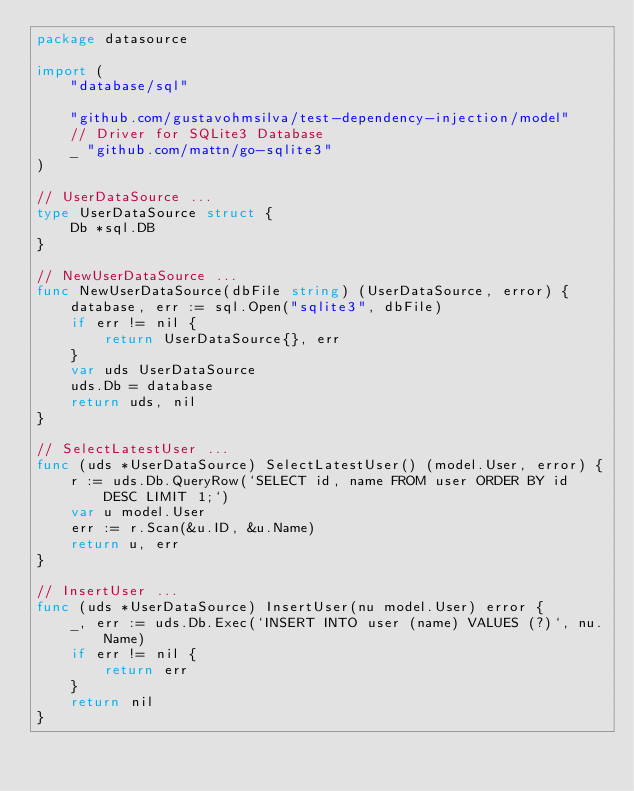Convert code to text. <code><loc_0><loc_0><loc_500><loc_500><_Go_>package datasource

import (
	"database/sql"

	"github.com/gustavohmsilva/test-dependency-injection/model"
	// Driver for SQLite3 Database
	_ "github.com/mattn/go-sqlite3"
)

// UserDataSource ...
type UserDataSource struct {
	Db *sql.DB
}

// NewUserDataSource ...
func NewUserDataSource(dbFile string) (UserDataSource, error) {
	database, err := sql.Open("sqlite3", dbFile)
	if err != nil {
		return UserDataSource{}, err
	}
	var uds UserDataSource
	uds.Db = database
	return uds, nil
}

// SelectLatestUser ...
func (uds *UserDataSource) SelectLatestUser() (model.User, error) {
	r := uds.Db.QueryRow(`SELECT id, name FROM user ORDER BY id DESC LIMIT 1;`)
	var u model.User
	err := r.Scan(&u.ID, &u.Name)
	return u, err
}

// InsertUser ...
func (uds *UserDataSource) InsertUser(nu model.User) error {
	_, err := uds.Db.Exec(`INSERT INTO user (name) VALUES (?)`, nu.Name)
	if err != nil {
		return err
	}
	return nil
}
</code> 